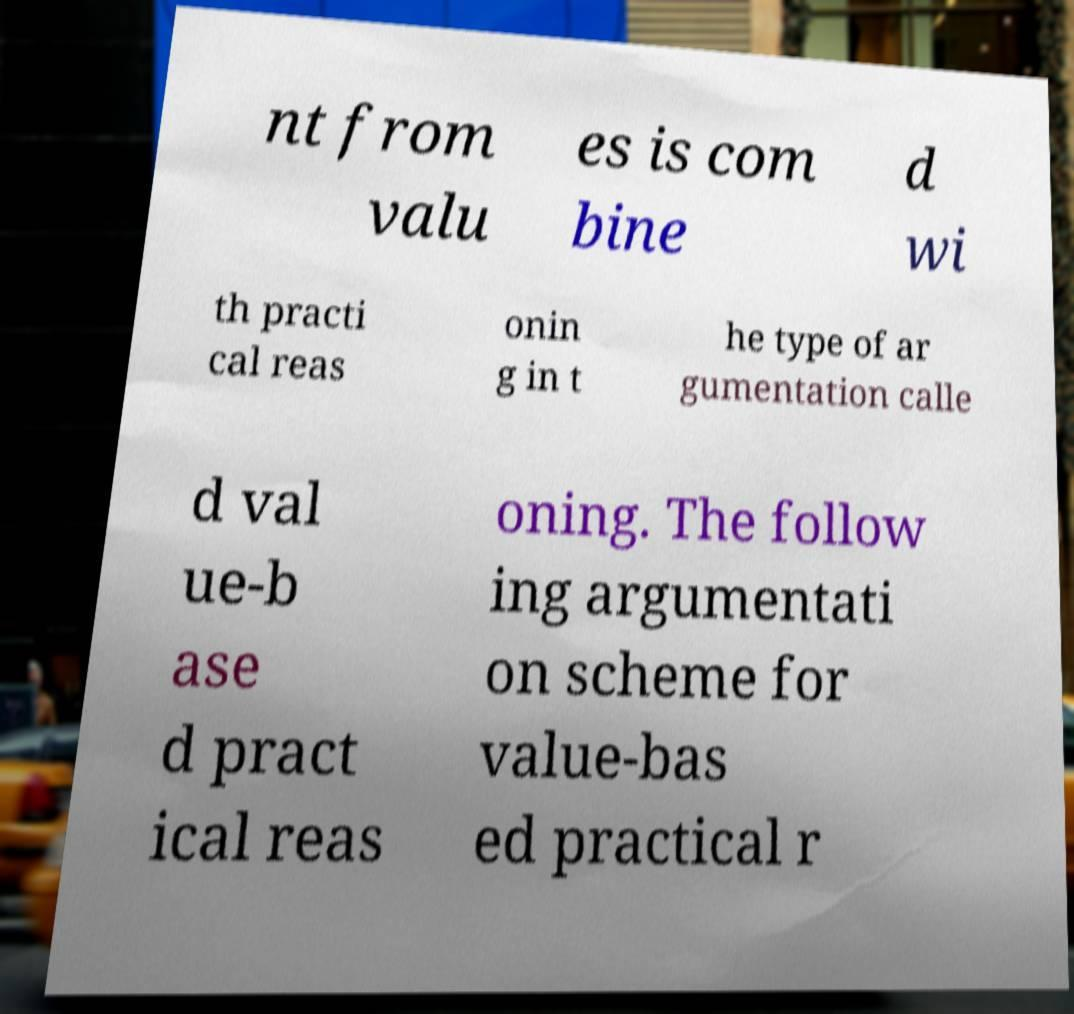Can you read and provide the text displayed in the image?This photo seems to have some interesting text. Can you extract and type it out for me? nt from valu es is com bine d wi th practi cal reas onin g in t he type of ar gumentation calle d val ue-b ase d pract ical reas oning. The follow ing argumentati on scheme for value-bas ed practical r 